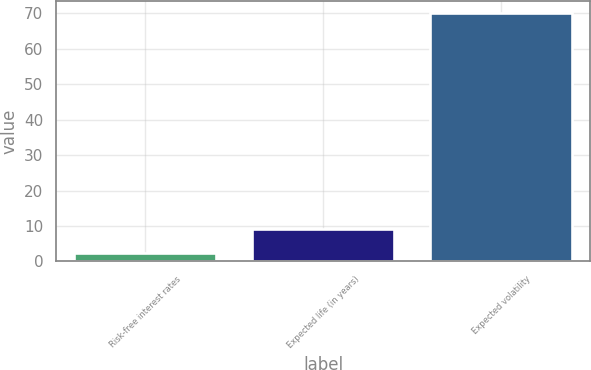<chart> <loc_0><loc_0><loc_500><loc_500><bar_chart><fcel>Risk-free interest rates<fcel>Expected life (in years)<fcel>Expected volatility<nl><fcel>2.5<fcel>9.25<fcel>70<nl></chart> 